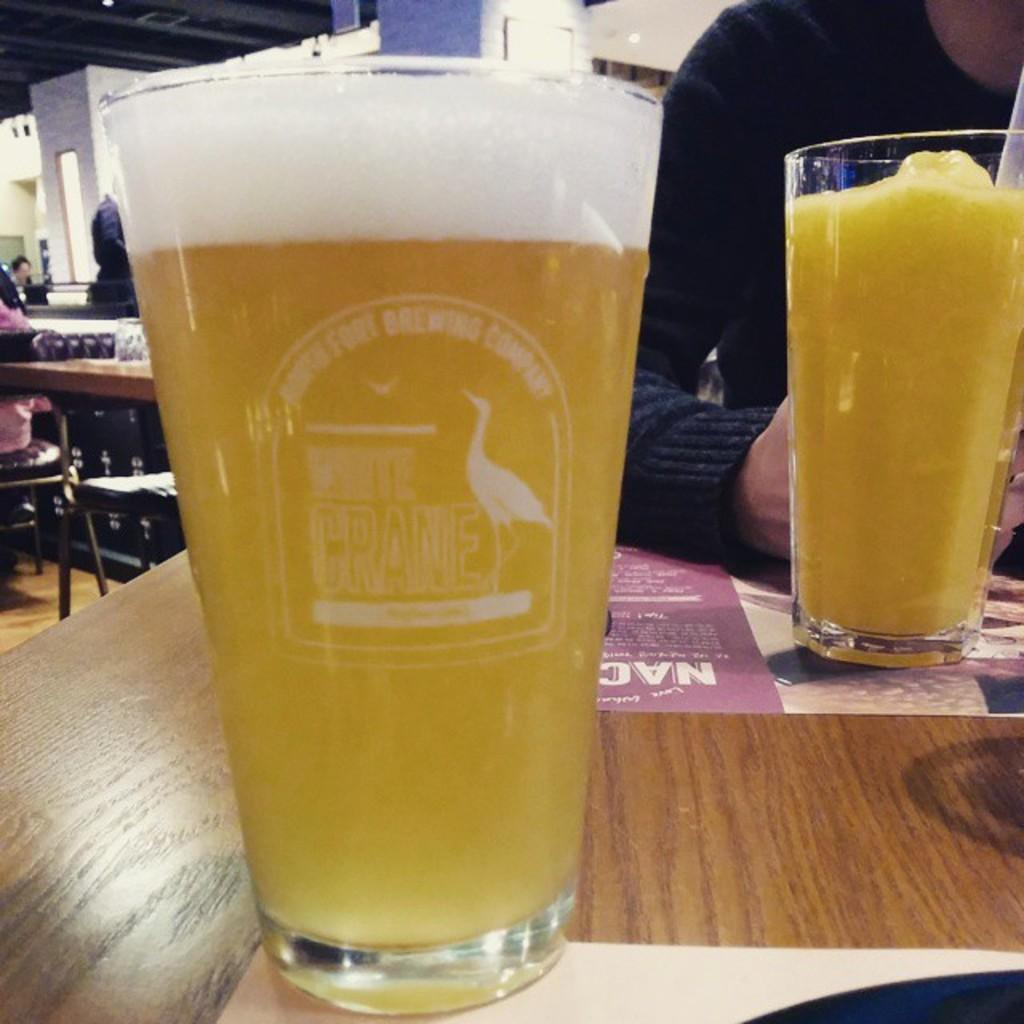What piece of furniture is present in the image? There is a table in the image. What objects are on the table? There are juice glasses on the table. What type of print can be seen on the tablecloth in the image? There is no tablecloth present in the image, so it is not possible to determine if there is any print on it. 